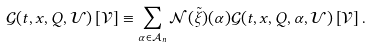Convert formula to latex. <formula><loc_0><loc_0><loc_500><loc_500>\mathcal { G } ( t , x , Q , \mathcal { U } ) \left [ \mathcal { V } \right ] \equiv \sum _ { \alpha \in \mathcal { A } _ { n } } \mathcal { N } ( \tilde { \xi } ) ( \alpha ) \mathcal { G } ( t , x , Q , \alpha , \mathcal { U } ) \left [ \mathcal { V } \right ] .</formula> 